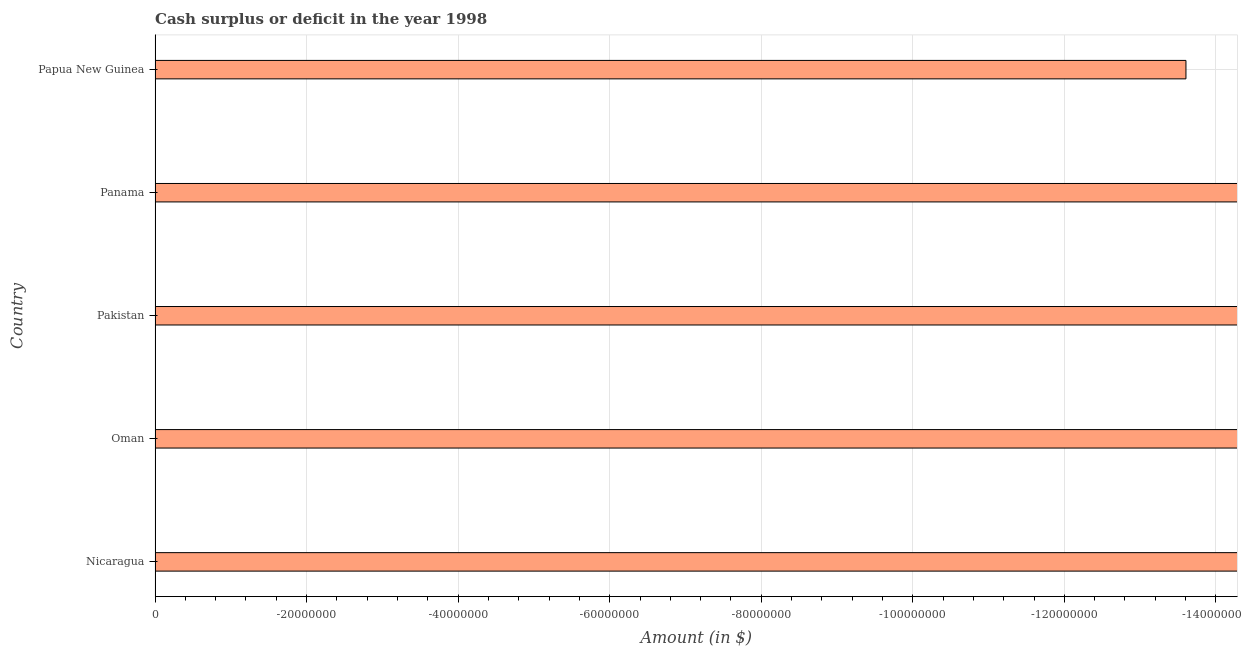Does the graph contain any zero values?
Offer a very short reply. Yes. Does the graph contain grids?
Your response must be concise. Yes. What is the title of the graph?
Your response must be concise. Cash surplus or deficit in the year 1998. What is the label or title of the X-axis?
Provide a short and direct response. Amount (in $). What is the label or title of the Y-axis?
Offer a very short reply. Country. What is the cash surplus or deficit in Oman?
Give a very brief answer. 0. What is the sum of the cash surplus or deficit?
Ensure brevity in your answer.  0. What is the median cash surplus or deficit?
Offer a terse response. 0. How many bars are there?
Ensure brevity in your answer.  0. Are all the bars in the graph horizontal?
Your response must be concise. Yes. Are the values on the major ticks of X-axis written in scientific E-notation?
Offer a terse response. No. What is the Amount (in $) of Oman?
Provide a succinct answer. 0. What is the Amount (in $) of Papua New Guinea?
Provide a short and direct response. 0. 